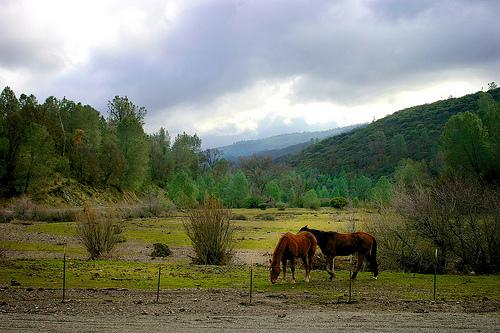Question: how are these horses being raised?
Choices:
A. In a pen.
B. On a farm.
C. Free Range.
D. In the wild.
Answer with the letter. Answer: C Question: what can a person do with the tails of these horses?
Choices:
A. Pull them.
B. Brush them.
C. Braid them.
D. Clean them.
Answer with the letter. Answer: C Question: what is the red horse doing?
Choices:
A. Drinking.
B. Eating.
C. Running.
D. Walking.
Answer with the letter. Answer: B 